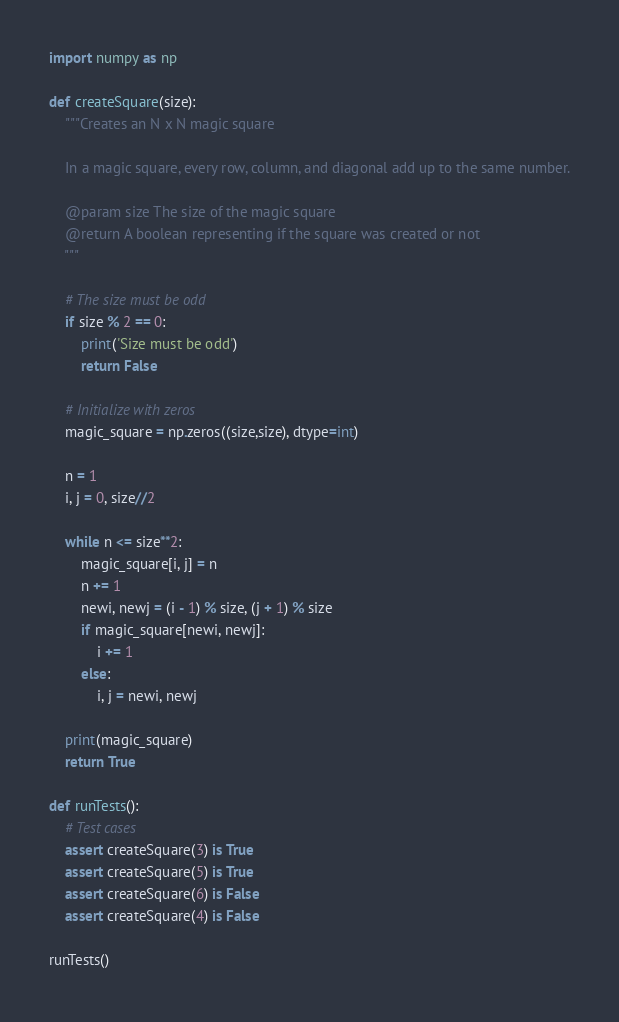<code> <loc_0><loc_0><loc_500><loc_500><_Python_>import numpy as np

def createSquare(size):
    """Creates an N x N magic square
    
    In a magic square, every row, column, and diagonal add up to the same number.
    
    @param size The size of the magic square
    @return A boolean representing if the square was created or not
    """
    
    # The size must be odd
    if size % 2 == 0:
        print('Size must be odd')
        return False

    # Initialize with zeros
    magic_square = np.zeros((size,size), dtype=int)

    n = 1
    i, j = 0, size//2

    while n <= size**2:
        magic_square[i, j] = n
        n += 1
        newi, newj = (i - 1) % size, (j + 1) % size
        if magic_square[newi, newj]:
            i += 1
        else:
            i, j = newi, newj

    print(magic_square)
    return True

def runTests():
    # Test cases
    assert createSquare(3) is True
    assert createSquare(5) is True
    assert createSquare(6) is False
    assert createSquare(4) is False

runTests()
</code> 